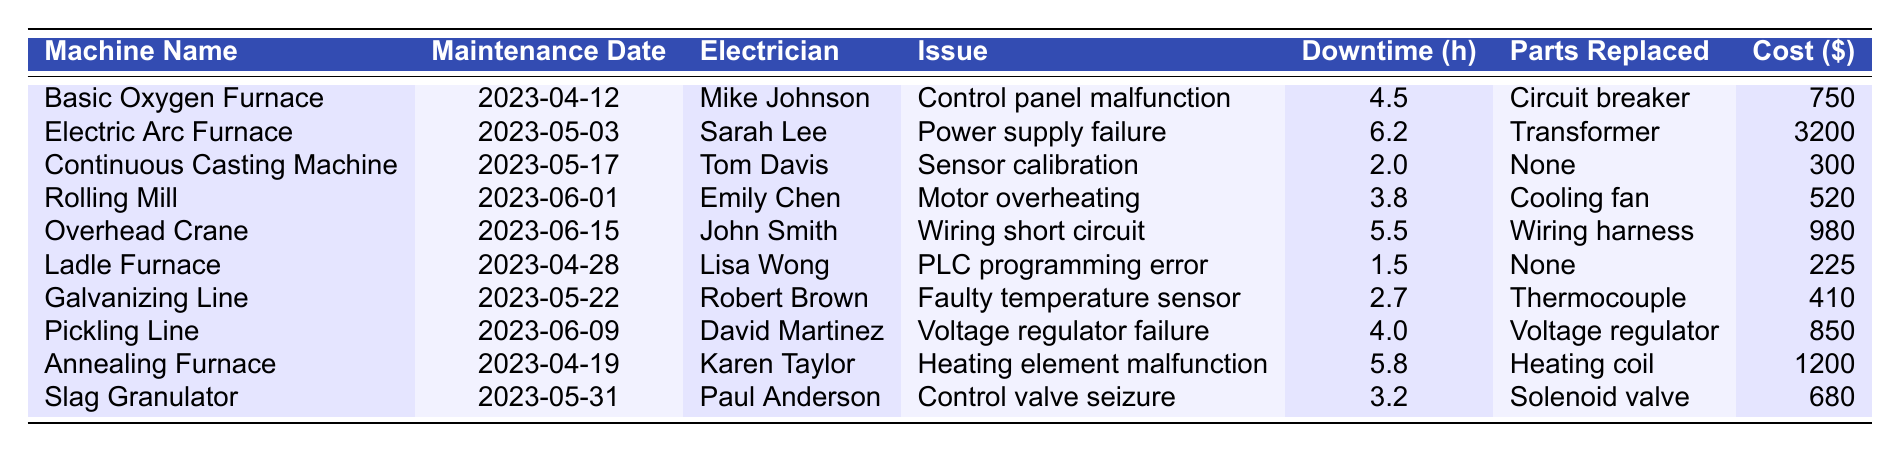What was the longest downtime recorded for any machine? The longest recorded downtime can be found in the 'Downtime (hours)' column. The value is 6.2 hours for the Electric Arc Furnace.
Answer: 6.2 hours Which machine had the highest maintenance cost? To determine the highest maintenance cost, we look at the 'Cost ($)' column. The highest cost is 3200 dollars for the Electric Arc Furnace.
Answer: 3200 dollars Did any of the machines require parts to be replaced during maintenance? We check the 'Parts Replaced' column for entries that indicate a part was replaced. Yes, several machines have specified parts that were replaced, such as the Circuit breaker and Transformer.
Answer: Yes What was the total downtime of the Basic Oxygen Furnace and the Annealing Furnace combined? To find the total downtime, we add the downtime of both machines: 4.5 hours (Basic Oxygen Furnace) + 5.8 hours (Annealing Furnace) = 10.3 hours.
Answer: 10.3 hours Who was the electrician for the Overhead Crane maintenance? The 'Electrician' column shows that John Smith was responsible for the Overhead Crane maintenance.
Answer: John Smith Is it true that the Continuous Casting Machine had no parts replaced during its maintenance? By inspecting the 'Parts Replaced' column for the Continuous Casting Machine, it is indicated as “None.” Therefore, the statement is true.
Answer: Yes What is the average cost of maintenance across all machines? To calculate the average cost, first, sum all the costs: 750 + 3200 + 300 + 520 + 980 + 225 + 410 + 850 + 1200 + 680 = 10115. Then divide by the number of machines, which is 10. The average cost is 10115/10 = 1011.5 dollars.
Answer: 1011.5 dollars Which electrician had the highest total downtime associated with their maintenance work? We need to tally the downtimes associated with each electrician. For example, Mike Johnson has 4.5 hours, Sarah Lee has 6.2 hours, and so forth. Upon summation, Sarah Lee has the highest downtime total with 6.2 hours.
Answer: Sarah Lee What issue was reported for the Slag Granulator? The issue is listed in the 'Issue' column, which states the problem was a control valve seizure.
Answer: Control valve seizure How many machines required wiring-related repairs? By reviewing the 'Issue' column, the Overhead Crane had a wiring short circuit. Therefore, only one machine required wiring-related repairs.
Answer: 1 machine 